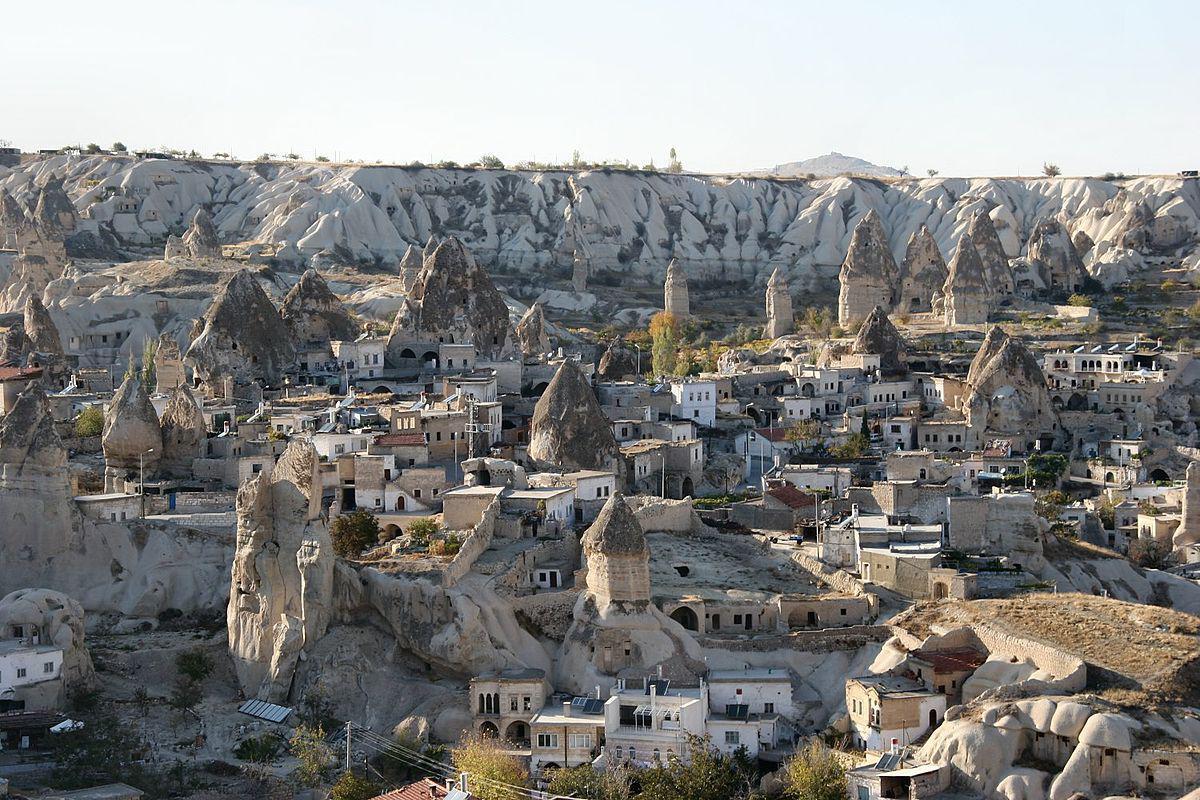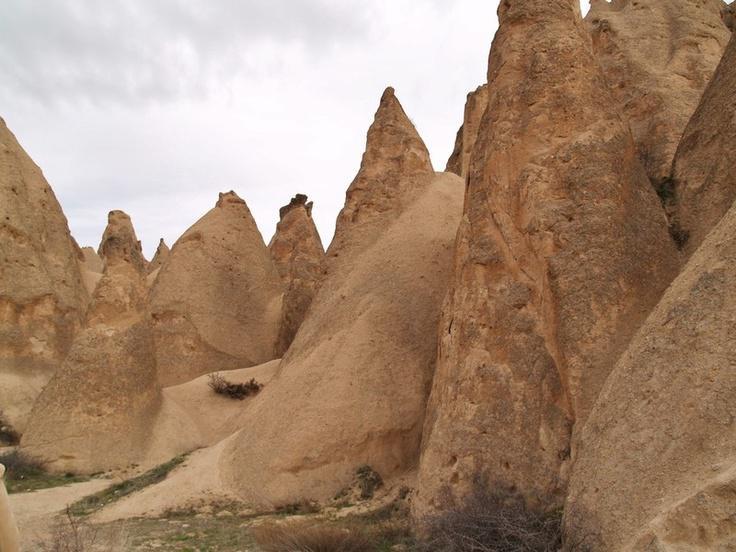The first image is the image on the left, the second image is the image on the right. Assess this claim about the two images: "In at least one image there is a single large cloud over at least seven triangle rock structures.". Correct or not? Answer yes or no. Yes. The first image is the image on the left, the second image is the image on the right. For the images displayed, is the sentence "There are more than three  buildings in the right image, and mountains in the left image." factually correct? Answer yes or no. No. 